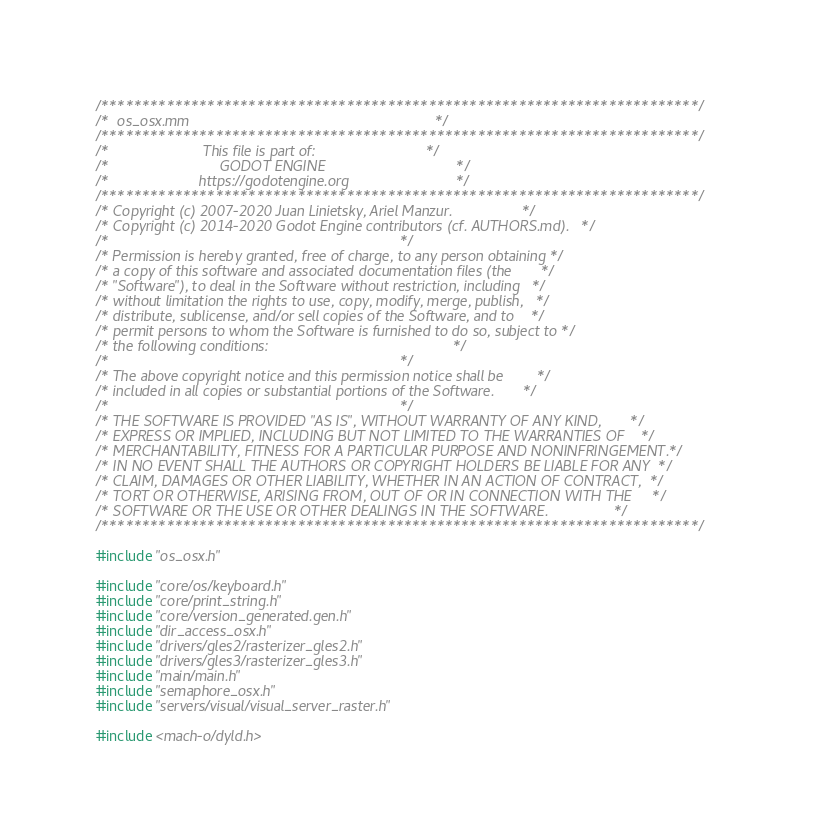Convert code to text. <code><loc_0><loc_0><loc_500><loc_500><_ObjectiveC_>/*************************************************************************/
/*  os_osx.mm                                                            */
/*************************************************************************/
/*                       This file is part of:                           */
/*                           GODOT ENGINE                                */
/*                      https://godotengine.org                          */
/*************************************************************************/
/* Copyright (c) 2007-2020 Juan Linietsky, Ariel Manzur.                 */
/* Copyright (c) 2014-2020 Godot Engine contributors (cf. AUTHORS.md).   */
/*                                                                       */
/* Permission is hereby granted, free of charge, to any person obtaining */
/* a copy of this software and associated documentation files (the       */
/* "Software"), to deal in the Software without restriction, including   */
/* without limitation the rights to use, copy, modify, merge, publish,   */
/* distribute, sublicense, and/or sell copies of the Software, and to    */
/* permit persons to whom the Software is furnished to do so, subject to */
/* the following conditions:                                             */
/*                                                                       */
/* The above copyright notice and this permission notice shall be        */
/* included in all copies or substantial portions of the Software.       */
/*                                                                       */
/* THE SOFTWARE IS PROVIDED "AS IS", WITHOUT WARRANTY OF ANY KIND,       */
/* EXPRESS OR IMPLIED, INCLUDING BUT NOT LIMITED TO THE WARRANTIES OF    */
/* MERCHANTABILITY, FITNESS FOR A PARTICULAR PURPOSE AND NONINFRINGEMENT.*/
/* IN NO EVENT SHALL THE AUTHORS OR COPYRIGHT HOLDERS BE LIABLE FOR ANY  */
/* CLAIM, DAMAGES OR OTHER LIABILITY, WHETHER IN AN ACTION OF CONTRACT,  */
/* TORT OR OTHERWISE, ARISING FROM, OUT OF OR IN CONNECTION WITH THE     */
/* SOFTWARE OR THE USE OR OTHER DEALINGS IN THE SOFTWARE.                */
/*************************************************************************/

#include "os_osx.h"

#include "core/os/keyboard.h"
#include "core/print_string.h"
#include "core/version_generated.gen.h"
#include "dir_access_osx.h"
#include "drivers/gles2/rasterizer_gles2.h"
#include "drivers/gles3/rasterizer_gles3.h"
#include "main/main.h"
#include "semaphore_osx.h"
#include "servers/visual/visual_server_raster.h"

#include <mach-o/dyld.h>
</code> 